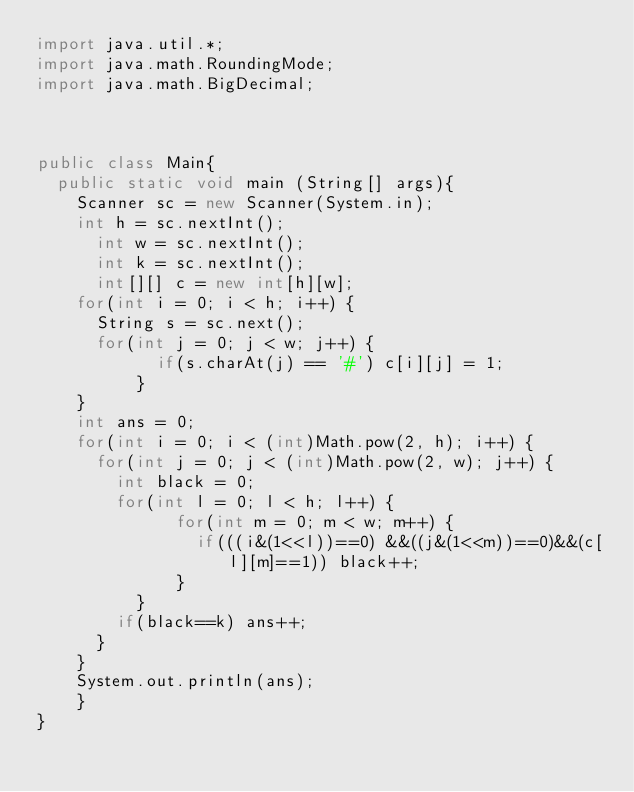<code> <loc_0><loc_0><loc_500><loc_500><_Java_>import java.util.*;
import java.math.RoundingMode;
import java.math.BigDecimal;
 
 
 
public class Main{
	public static void main (String[] args){
		Scanner sc = new Scanner(System.in);
		int h = sc.nextInt();
	    int w = sc.nextInt();
	    int k = sc.nextInt();
	    int[][] c = new int[h][w];
		for(int i = 0; i < h; i++) {
			String s = sc.next();
			for(int j = 0; j < w; j++) {
		        if(s.charAt(j) == '#') c[i][j] = 1;
		      }
		}
		int ans = 0;
		for(int i = 0; i < (int)Math.pow(2, h); i++) {
			for(int j = 0; j < (int)Math.pow(2, w); j++) {
				int black = 0;
				for(int l = 0; l < h; l++) {
			        for(int m = 0; m < w; m++) {
			        	if(((i&(1<<l))==0) &&((j&(1<<m))==0)&&(c[l][m]==1)) black++; 
			        }
			    }
				if(black==k) ans++;
			}
		}
		System.out.println(ans);
    }
}</code> 